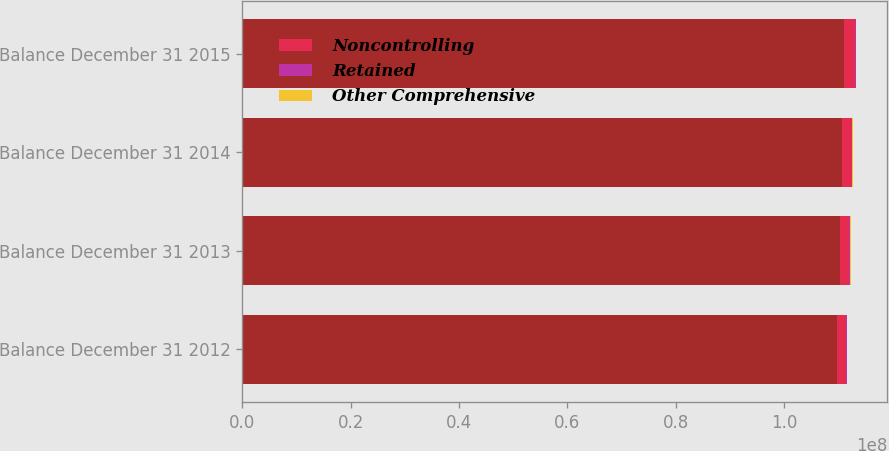Convert chart. <chart><loc_0><loc_0><loc_500><loc_500><stacked_bar_chart><ecel><fcel>Balance December 31 2012<fcel>Balance December 31 2013<fcel>Balance December 31 2014<fcel>Balance December 31 2015<nl><fcel>nan<fcel>1.09838e+08<fcel>1.10281e+08<fcel>1.1065e+08<fcel>1.11095e+08<nl><fcel>Noncontrolling<fcel>1.6241e+06<fcel>1.78527e+06<fcel>1.92606e+06<fcel>2.0928e+06<nl><fcel>Retained<fcel>114008<fcel>78053<fcel>68141<fcel>44748<nl><fcel>Other Comprehensive<fcel>129483<fcel>145990<fcel>151609<fcel>135540<nl></chart> 